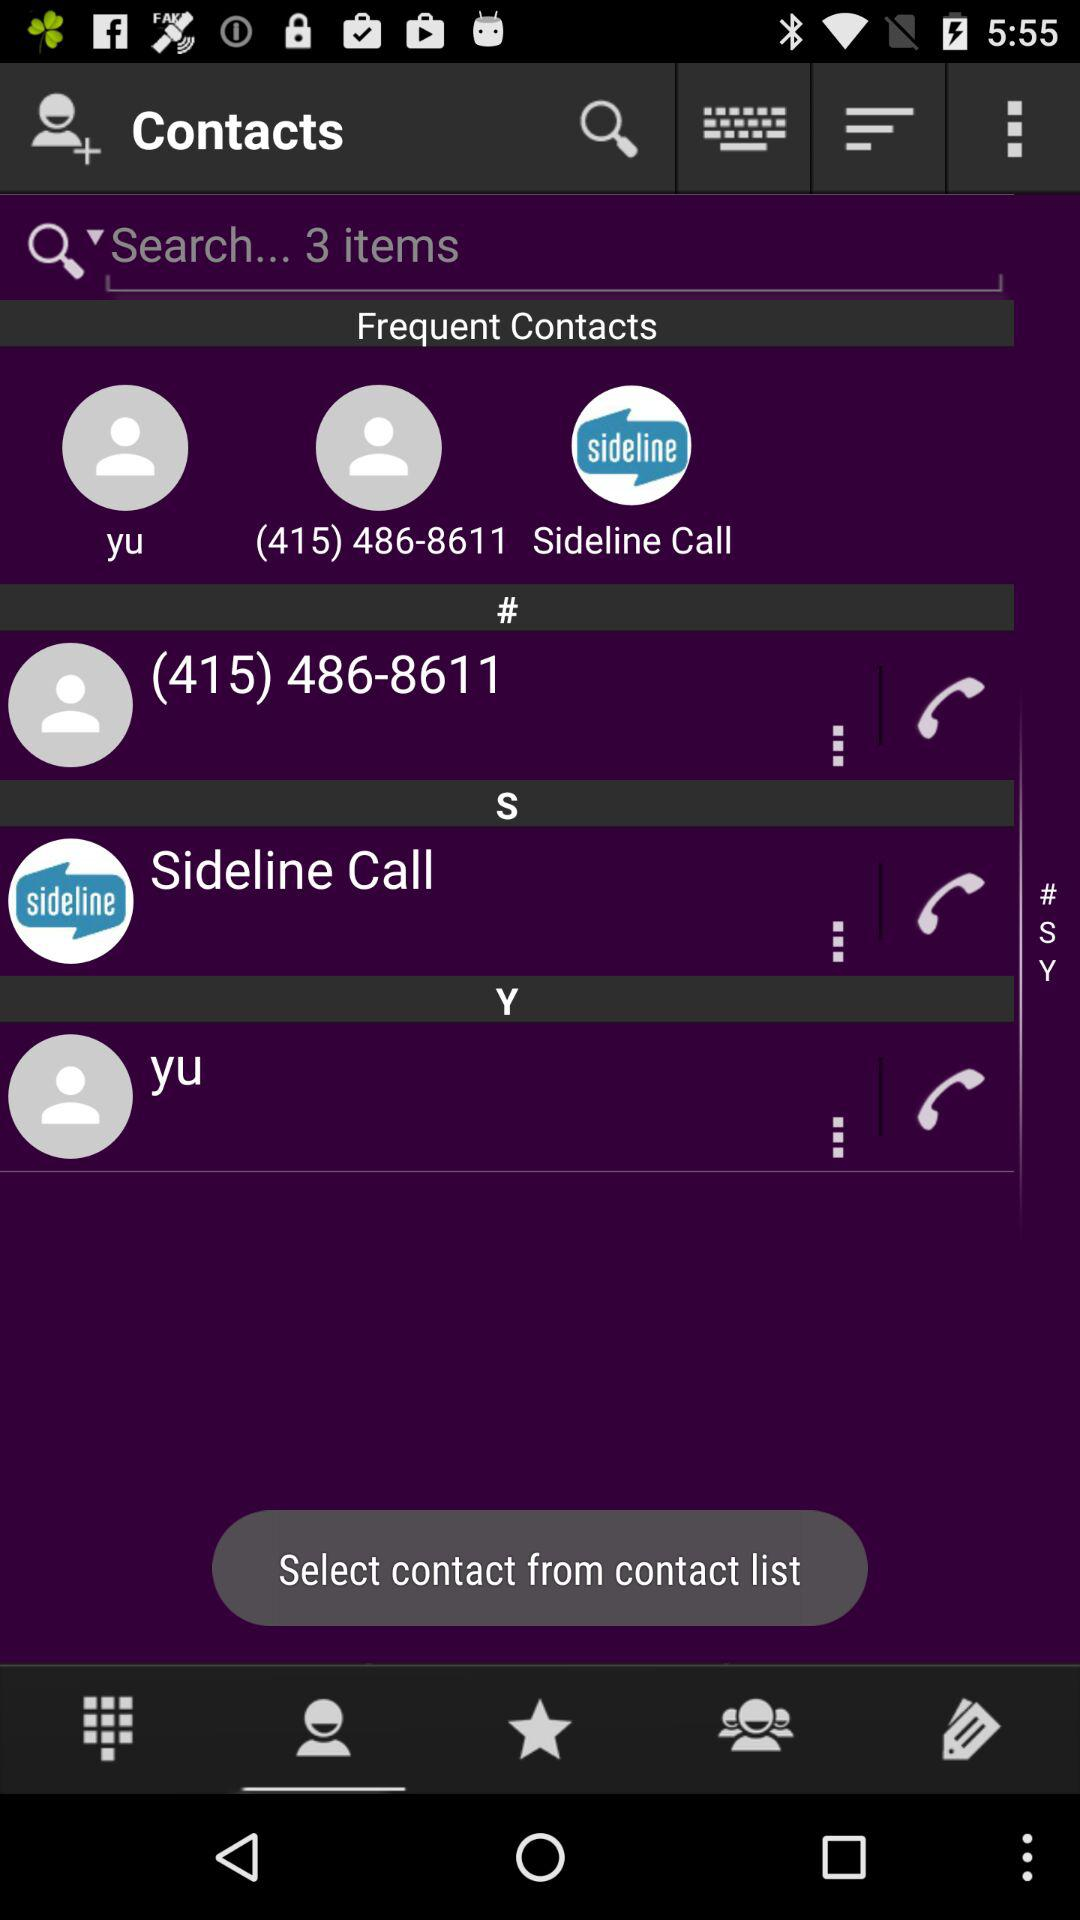What is the profile name?
When the provided information is insufficient, respond with <no answer>. <no answer> 